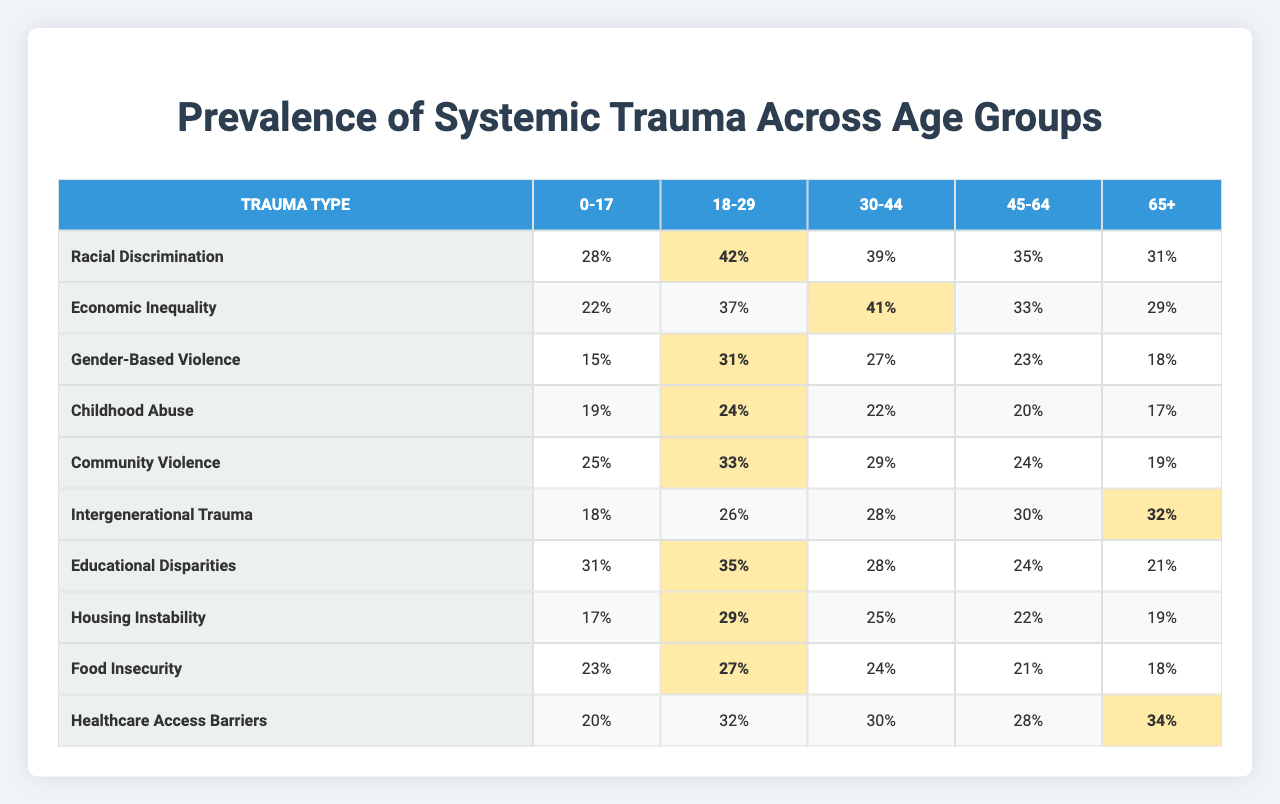What is the highest prevalence of Racial Discrimination and in which age group does it occur? According to the table, the highest prevalence of Racial Discrimination is 42%, which occurs in the 18-29 age group.
Answer: 42% in the 18-29 age group Which age group has the lowest prevalence of Gender-Based Violence? The lowest prevalence of Gender-Based Violence is 15%, found in the 0-17 age group.
Answer: 15% in the 0-17 age group What is the average prevalence of Economic Inequality across all age groups? To calculate the average, we sum the values: (22 + 37 + 41 + 33 + 29) = 162, and then divide by 5 age groups: 162/5 = 32.4.
Answer: 32.4% Is the prevalence of childhood abuse higher in the 30-44 age group compared to the 45-64 age group? In the table, Childhood Abuse prevalence is 22% in the 30-44 age group and 20% in the 45-64 age group. Therefore, it is indeed higher in the 30-44 age group.
Answer: Yes What is the difference in prevalence of Community Violence between the 18-29 and 65+ age groups? The prevalence of Community Violence is 33% for the 18-29 age group and 19% for the 65+ age group. The difference is 33% - 19% = 14%.
Answer: 14% Which trauma type has the highest prevalence among individuals aged 0-17? Looking at the 0-17 age group column, Educational Disparities has the highest prevalence at 31%.
Answer: 31% for Educational Disparities What is the total prevalence of Healthcare Access Barriers across all age groups? Summing the prevalence values: (20 + 32 + 30 + 28 + 34) = 144%. Therefore, the total prevalence is 144%.
Answer: 144% Is Food Insecurity more prevalent in the 18-29 age group compared to the 30-44 age group? The prevalence of Food Insecurity is 27% for the 18-29 age group and 24% for the 30-44 age group. This means it is more prevalent in the 18-29 age group.
Answer: Yes What is the median prevalence of Intergenerational Trauma across all age groups? The prevalence values for Intergenerational Trauma are: 18, 26, 28, 30, and 32. When arranged, the middle value (median) is 28%.
Answer: 28% Which age group experiences the highest prevalence of Housing Instability, and what is that percentage? The highest prevalence of Housing Instability is 29%, found in the 18-29 age group.
Answer: 29% in the 18-29 age group What is the percentage difference between the highest and lowest prevalence of Educational Disparities among the age groups? The highest prevalence of Educational Disparities is 31% (in the 0-17 age group) and the lowest is 21% (in the 65+ age group). The percentage difference is 31% - 21% = 10%.
Answer: 10% 